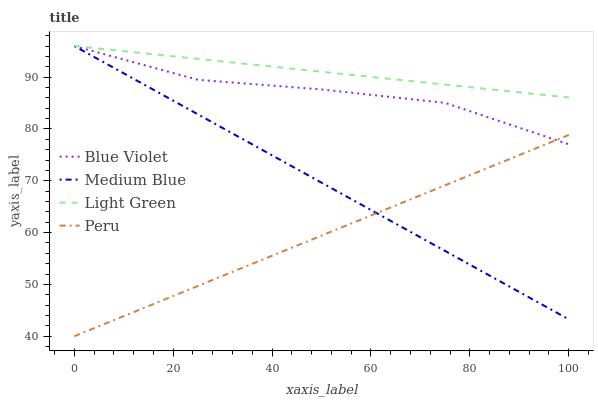Does Medium Blue have the minimum area under the curve?
Answer yes or no. No. Does Medium Blue have the maximum area under the curve?
Answer yes or no. No. Is Medium Blue the smoothest?
Answer yes or no. No. Is Medium Blue the roughest?
Answer yes or no. No. Does Medium Blue have the lowest value?
Answer yes or no. No. Is Peru less than Light Green?
Answer yes or no. Yes. Is Light Green greater than Peru?
Answer yes or no. Yes. Does Peru intersect Light Green?
Answer yes or no. No. 